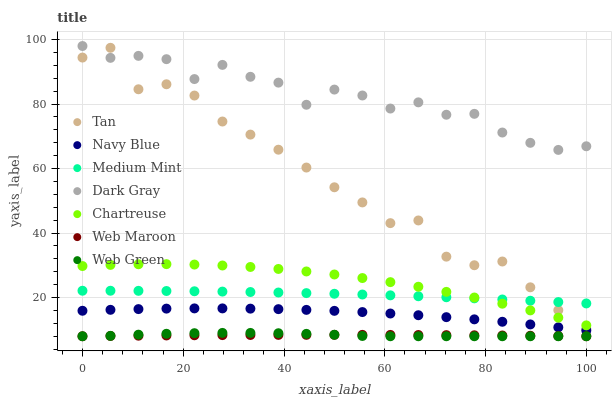Does Web Maroon have the minimum area under the curve?
Answer yes or no. Yes. Does Dark Gray have the maximum area under the curve?
Answer yes or no. Yes. Does Navy Blue have the minimum area under the curve?
Answer yes or no. No. Does Navy Blue have the maximum area under the curve?
Answer yes or no. No. Is Web Maroon the smoothest?
Answer yes or no. Yes. Is Tan the roughest?
Answer yes or no. Yes. Is Navy Blue the smoothest?
Answer yes or no. No. Is Navy Blue the roughest?
Answer yes or no. No. Does Web Maroon have the lowest value?
Answer yes or no. Yes. Does Navy Blue have the lowest value?
Answer yes or no. No. Does Dark Gray have the highest value?
Answer yes or no. Yes. Does Navy Blue have the highest value?
Answer yes or no. No. Is Web Maroon less than Chartreuse?
Answer yes or no. Yes. Is Chartreuse greater than Web Maroon?
Answer yes or no. Yes. Does Chartreuse intersect Medium Mint?
Answer yes or no. Yes. Is Chartreuse less than Medium Mint?
Answer yes or no. No. Is Chartreuse greater than Medium Mint?
Answer yes or no. No. Does Web Maroon intersect Chartreuse?
Answer yes or no. No. 